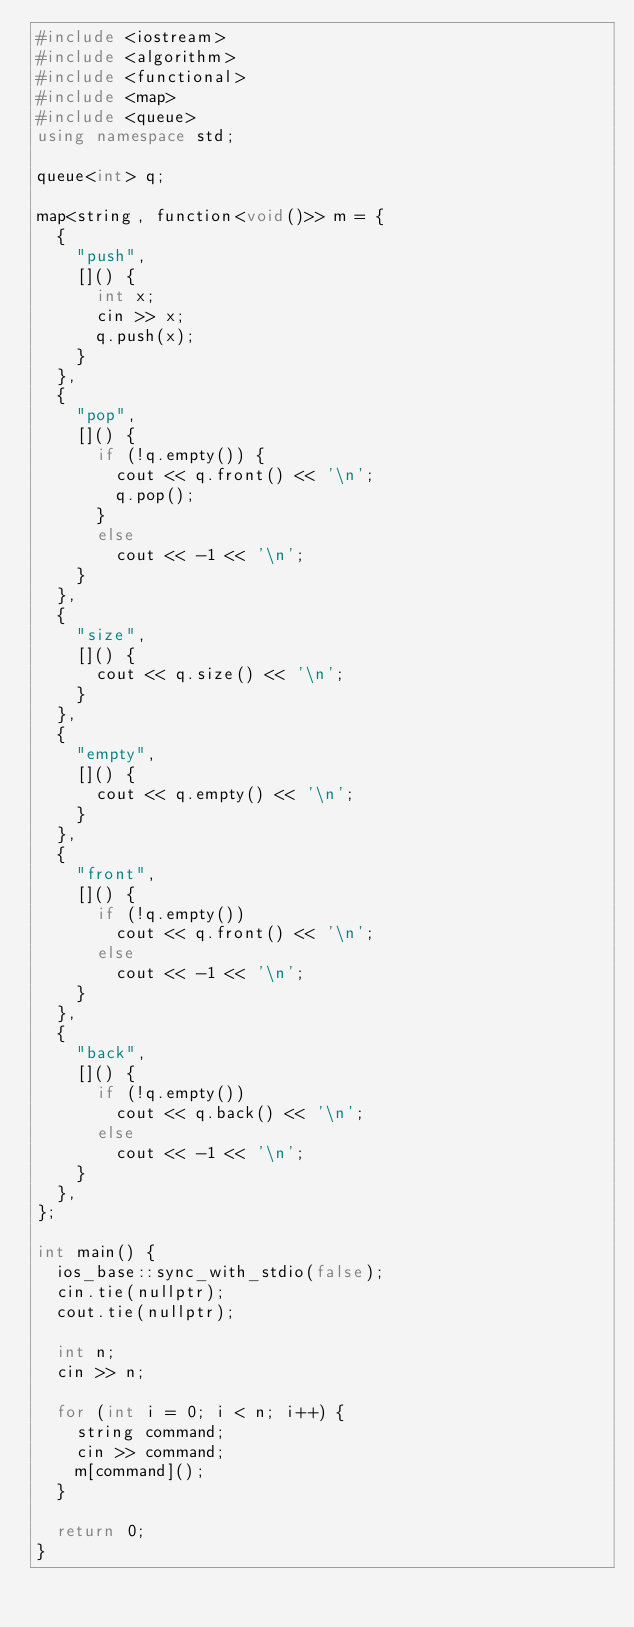<code> <loc_0><loc_0><loc_500><loc_500><_C++_>#include <iostream>
#include <algorithm>
#include <functional>
#include <map>
#include <queue>
using namespace std;

queue<int> q;

map<string, function<void()>> m = {
	{
		"push",
		[]() {
			int x;
			cin >> x;
			q.push(x);
		}
	},
	{
		"pop",
		[]() {
			if (!q.empty()) {
				cout << q.front() << '\n';
				q.pop();
			}
			else
				cout << -1 << '\n';
		}
	},
	{
		"size",
		[]() {
			cout << q.size() << '\n';
		}
	},
	{
		"empty",
		[]() {
			cout << q.empty() << '\n';
		}
	},
	{
		"front",
		[]() {
			if (!q.empty())
				cout << q.front() << '\n';
			else
				cout << -1 << '\n';
		}
	},
	{
		"back",
		[]() {
			if (!q.empty())
				cout << q.back() << '\n';
			else
				cout << -1 << '\n';
		}
	},
};

int main() {
	ios_base::sync_with_stdio(false);
	cin.tie(nullptr);
	cout.tie(nullptr);

	int n;
	cin >> n;

	for (int i = 0; i < n; i++) {
		string command;
		cin >> command;
		m[command]();
	}

	return 0;
}</code> 